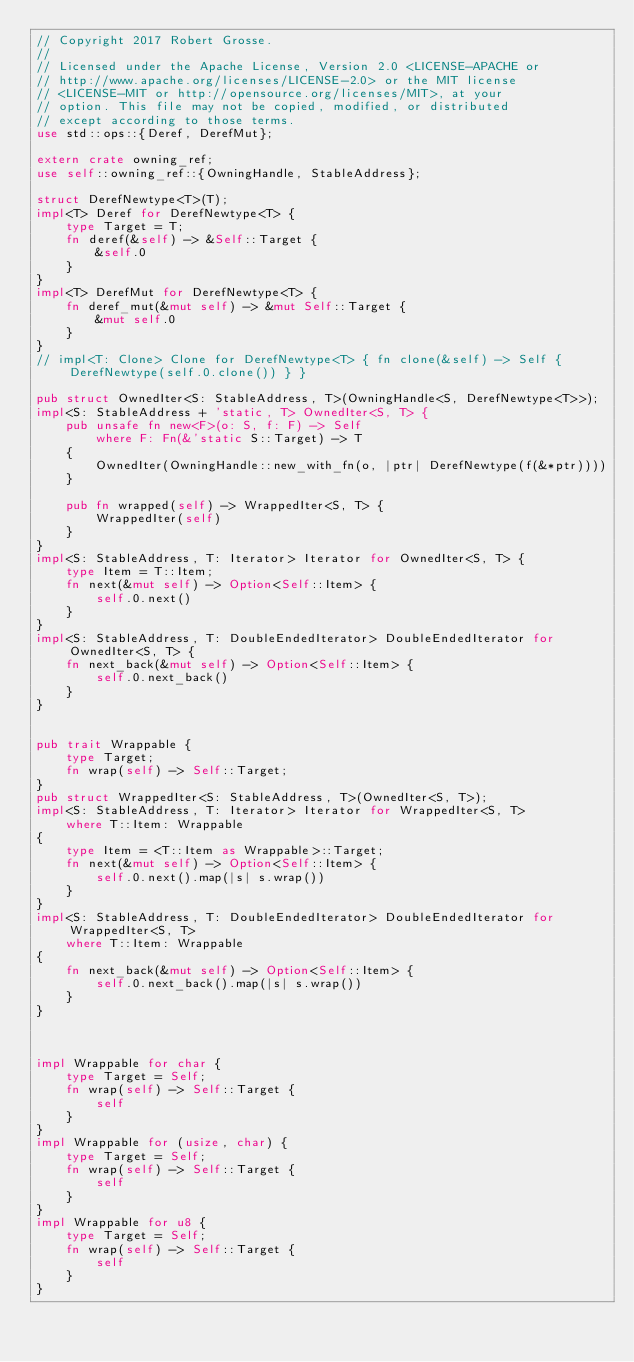Convert code to text. <code><loc_0><loc_0><loc_500><loc_500><_Rust_>// Copyright 2017 Robert Grosse.
//
// Licensed under the Apache License, Version 2.0 <LICENSE-APACHE or
// http://www.apache.org/licenses/LICENSE-2.0> or the MIT license
// <LICENSE-MIT or http://opensource.org/licenses/MIT>, at your
// option. This file may not be copied, modified, or distributed
// except according to those terms.
use std::ops::{Deref, DerefMut};

extern crate owning_ref;
use self::owning_ref::{OwningHandle, StableAddress};

struct DerefNewtype<T>(T);
impl<T> Deref for DerefNewtype<T> {
    type Target = T;
    fn deref(&self) -> &Self::Target {
        &self.0
    }
}
impl<T> DerefMut for DerefNewtype<T> {
    fn deref_mut(&mut self) -> &mut Self::Target {
        &mut self.0
    }
}
// impl<T: Clone> Clone for DerefNewtype<T> { fn clone(&self) -> Self { DerefNewtype(self.0.clone()) } }

pub struct OwnedIter<S: StableAddress, T>(OwningHandle<S, DerefNewtype<T>>);
impl<S: StableAddress + 'static, T> OwnedIter<S, T> {
    pub unsafe fn new<F>(o: S, f: F) -> Self
        where F: Fn(&'static S::Target) -> T
    {
        OwnedIter(OwningHandle::new_with_fn(o, |ptr| DerefNewtype(f(&*ptr))))
    }

    pub fn wrapped(self) -> WrappedIter<S, T> {
        WrappedIter(self)
    }
}
impl<S: StableAddress, T: Iterator> Iterator for OwnedIter<S, T> {
    type Item = T::Item;
    fn next(&mut self) -> Option<Self::Item> {
        self.0.next()
    }
}
impl<S: StableAddress, T: DoubleEndedIterator> DoubleEndedIterator for OwnedIter<S, T> {
    fn next_back(&mut self) -> Option<Self::Item> {
        self.0.next_back()
    }
}


pub trait Wrappable {
    type Target;
    fn wrap(self) -> Self::Target;
}
pub struct WrappedIter<S: StableAddress, T>(OwnedIter<S, T>);
impl<S: StableAddress, T: Iterator> Iterator for WrappedIter<S, T>
    where T::Item: Wrappable
{
    type Item = <T::Item as Wrappable>::Target;
    fn next(&mut self) -> Option<Self::Item> {
        self.0.next().map(|s| s.wrap())
    }
}
impl<S: StableAddress, T: DoubleEndedIterator> DoubleEndedIterator for WrappedIter<S, T>
    where T::Item: Wrappable
{
    fn next_back(&mut self) -> Option<Self::Item> {
        self.0.next_back().map(|s| s.wrap())
    }
}



impl Wrappable for char {
    type Target = Self;
    fn wrap(self) -> Self::Target {
        self
    }
}
impl Wrappable for (usize, char) {
    type Target = Self;
    fn wrap(self) -> Self::Target {
        self
    }
}
impl Wrappable for u8 {
    type Target = Self;
    fn wrap(self) -> Self::Target {
        self
    }
}
</code> 